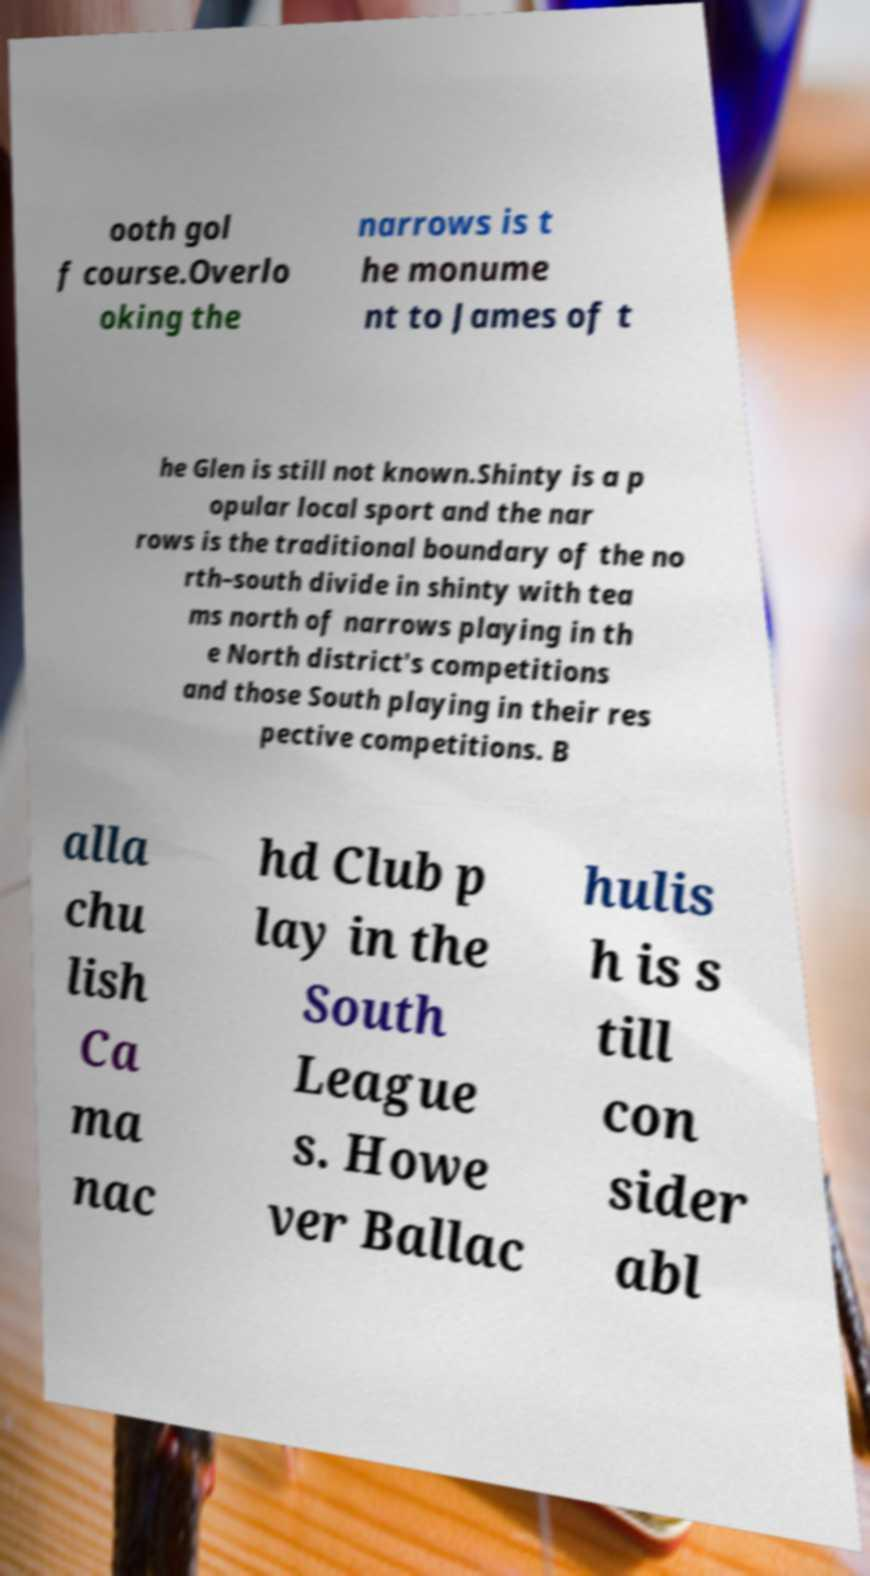For documentation purposes, I need the text within this image transcribed. Could you provide that? ooth gol f course.Overlo oking the narrows is t he monume nt to James of t he Glen is still not known.Shinty is a p opular local sport and the nar rows is the traditional boundary of the no rth–south divide in shinty with tea ms north of narrows playing in th e North district's competitions and those South playing in their res pective competitions. B alla chu lish Ca ma nac hd Club p lay in the South League s. Howe ver Ballac hulis h is s till con sider abl 